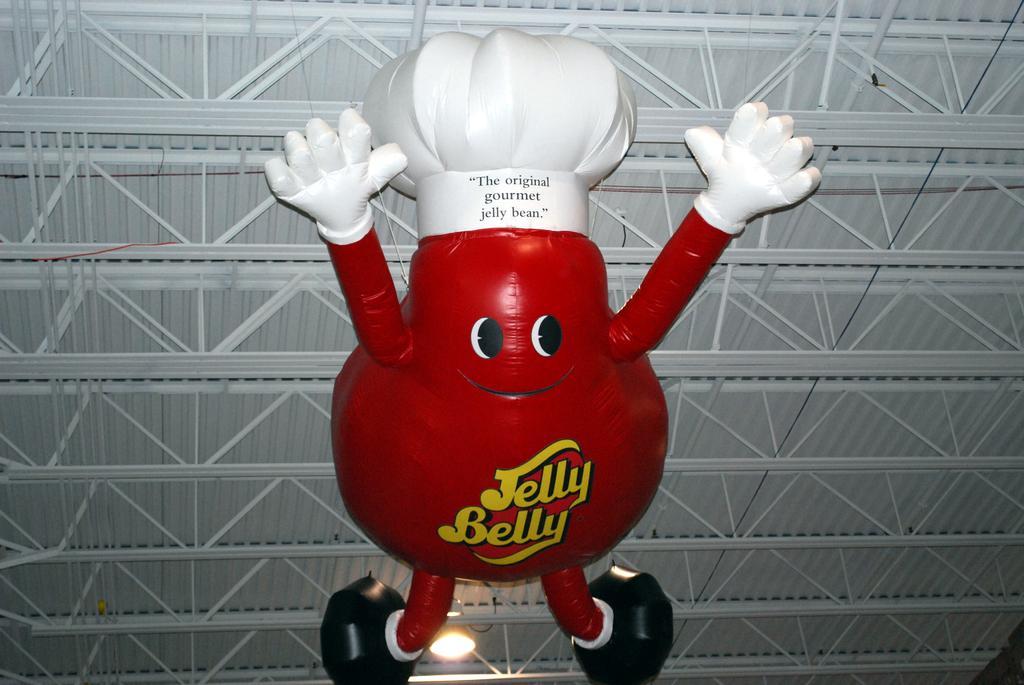Could you give a brief overview of what you see in this image? In this picture there is a red color cartoon balloon in the front. On the top there is a metal frame with shed. 